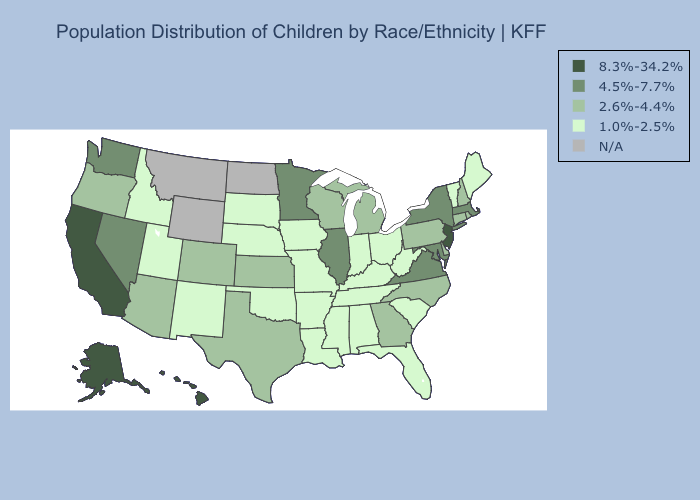Name the states that have a value in the range 8.3%-34.2%?
Give a very brief answer. Alaska, California, Hawaii, New Jersey. Which states have the lowest value in the USA?
Keep it brief. Alabama, Arkansas, Florida, Idaho, Indiana, Iowa, Kentucky, Louisiana, Maine, Mississippi, Missouri, Nebraska, New Mexico, Ohio, Oklahoma, South Carolina, South Dakota, Tennessee, Utah, Vermont, West Virginia. Among the states that border Washington , does Idaho have the highest value?
Be succinct. No. Name the states that have a value in the range 4.5%-7.7%?
Concise answer only. Illinois, Maryland, Massachusetts, Minnesota, Nevada, New York, Virginia, Washington. Which states have the lowest value in the Northeast?
Be succinct. Maine, Vermont. What is the highest value in states that border Oklahoma?
Write a very short answer. 2.6%-4.4%. Which states hav the highest value in the Northeast?
Keep it brief. New Jersey. What is the value of Colorado?
Answer briefly. 2.6%-4.4%. Name the states that have a value in the range 2.6%-4.4%?
Be succinct. Arizona, Colorado, Connecticut, Delaware, Georgia, Kansas, Michigan, New Hampshire, North Carolina, Oregon, Pennsylvania, Rhode Island, Texas, Wisconsin. What is the highest value in states that border Iowa?
Write a very short answer. 4.5%-7.7%. Is the legend a continuous bar?
Give a very brief answer. No. What is the value of Michigan?
Short answer required. 2.6%-4.4%. What is the value of Illinois?
Write a very short answer. 4.5%-7.7%. Among the states that border Wyoming , which have the lowest value?
Give a very brief answer. Idaho, Nebraska, South Dakota, Utah. 